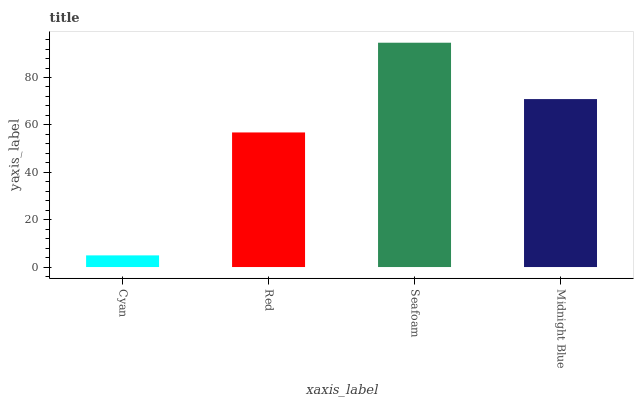Is Cyan the minimum?
Answer yes or no. Yes. Is Seafoam the maximum?
Answer yes or no. Yes. Is Red the minimum?
Answer yes or no. No. Is Red the maximum?
Answer yes or no. No. Is Red greater than Cyan?
Answer yes or no. Yes. Is Cyan less than Red?
Answer yes or no. Yes. Is Cyan greater than Red?
Answer yes or no. No. Is Red less than Cyan?
Answer yes or no. No. Is Midnight Blue the high median?
Answer yes or no. Yes. Is Red the low median?
Answer yes or no. Yes. Is Red the high median?
Answer yes or no. No. Is Seafoam the low median?
Answer yes or no. No. 